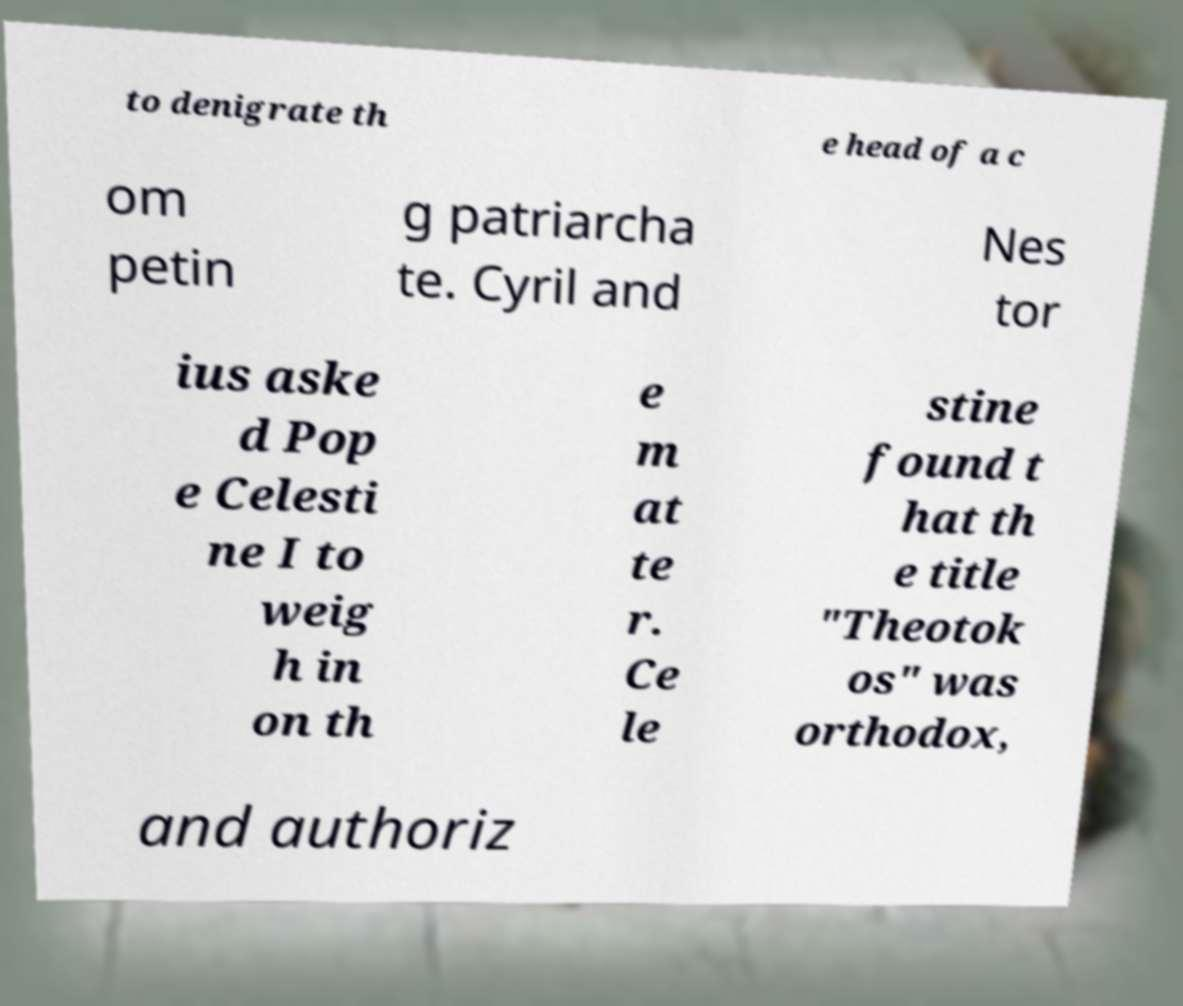For documentation purposes, I need the text within this image transcribed. Could you provide that? to denigrate th e head of a c om petin g patriarcha te. Cyril and Nes tor ius aske d Pop e Celesti ne I to weig h in on th e m at te r. Ce le stine found t hat th e title "Theotok os" was orthodox, and authoriz 